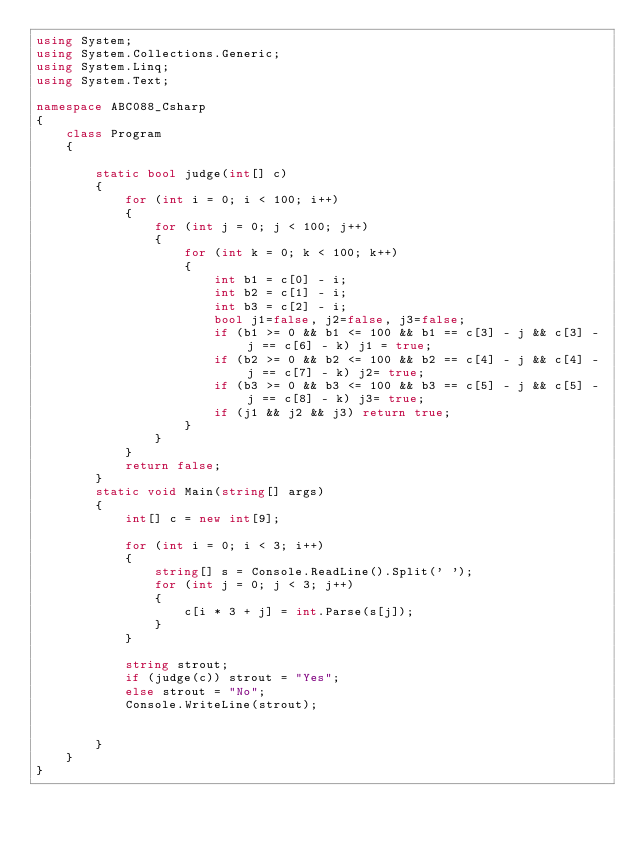<code> <loc_0><loc_0><loc_500><loc_500><_C#_>using System;
using System.Collections.Generic;
using System.Linq;
using System.Text;

namespace ABC088_Csharp
{
    class Program
    {

        static bool judge(int[] c)
        {
            for (int i = 0; i < 100; i++)
            {
                for (int j = 0; j < 100; j++)
                {
                    for (int k = 0; k < 100; k++)
                    {
                        int b1 = c[0] - i;
                        int b2 = c[1] - i;
                        int b3 = c[2] - i;
                        bool j1=false, j2=false, j3=false;
                        if (b1 >= 0 && b1 <= 100 && b1 == c[3] - j && c[3] - j == c[6] - k) j1 = true;
                        if (b2 >= 0 && b2 <= 100 && b2 == c[4] - j && c[4] - j == c[7] - k) j2= true;
                        if (b3 >= 0 && b3 <= 100 && b3 == c[5] - j && c[5] - j == c[8] - k) j3= true;
                        if (j1 && j2 && j3) return true;
                    }
                }
            }
            return false;
        }
        static void Main(string[] args)
        {
            int[] c = new int[9];

            for (int i = 0; i < 3; i++)
            {
                string[] s = Console.ReadLine().Split(' ');
                for (int j = 0; j < 3; j++)
                {
                    c[i * 3 + j] = int.Parse(s[j]);
                }
            }

            string strout;
            if (judge(c)) strout = "Yes";
            else strout = "No";
            Console.WriteLine(strout);


        }
    }
}
</code> 